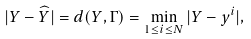Convert formula to latex. <formula><loc_0><loc_0><loc_500><loc_500>| Y - \widehat { Y } | = d ( Y , \Gamma ) = \min _ { 1 \leq i \leq N } | Y - y ^ { i } | ,</formula> 